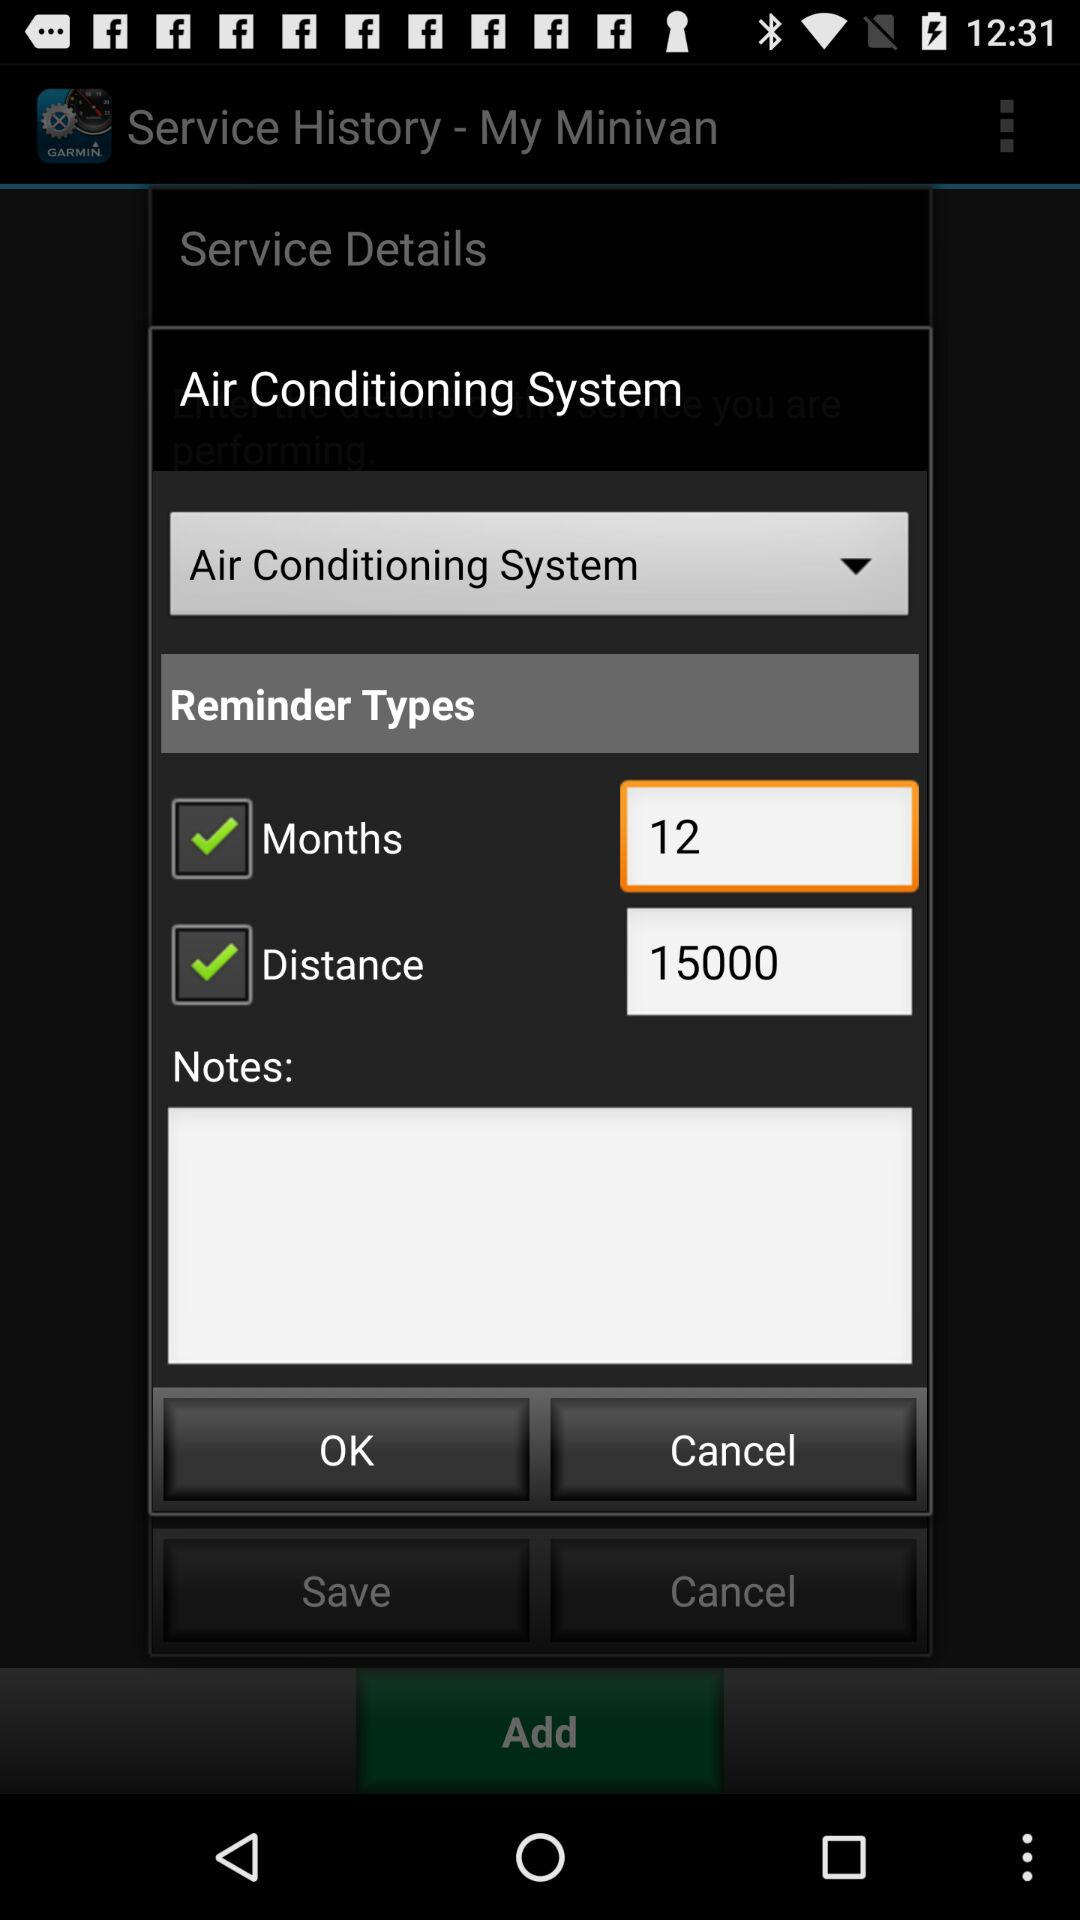How many months are there in the reminder type? There are 12 months in the reminder type. 